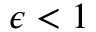Convert formula to latex. <formula><loc_0><loc_0><loc_500><loc_500>\epsilon < 1</formula> 